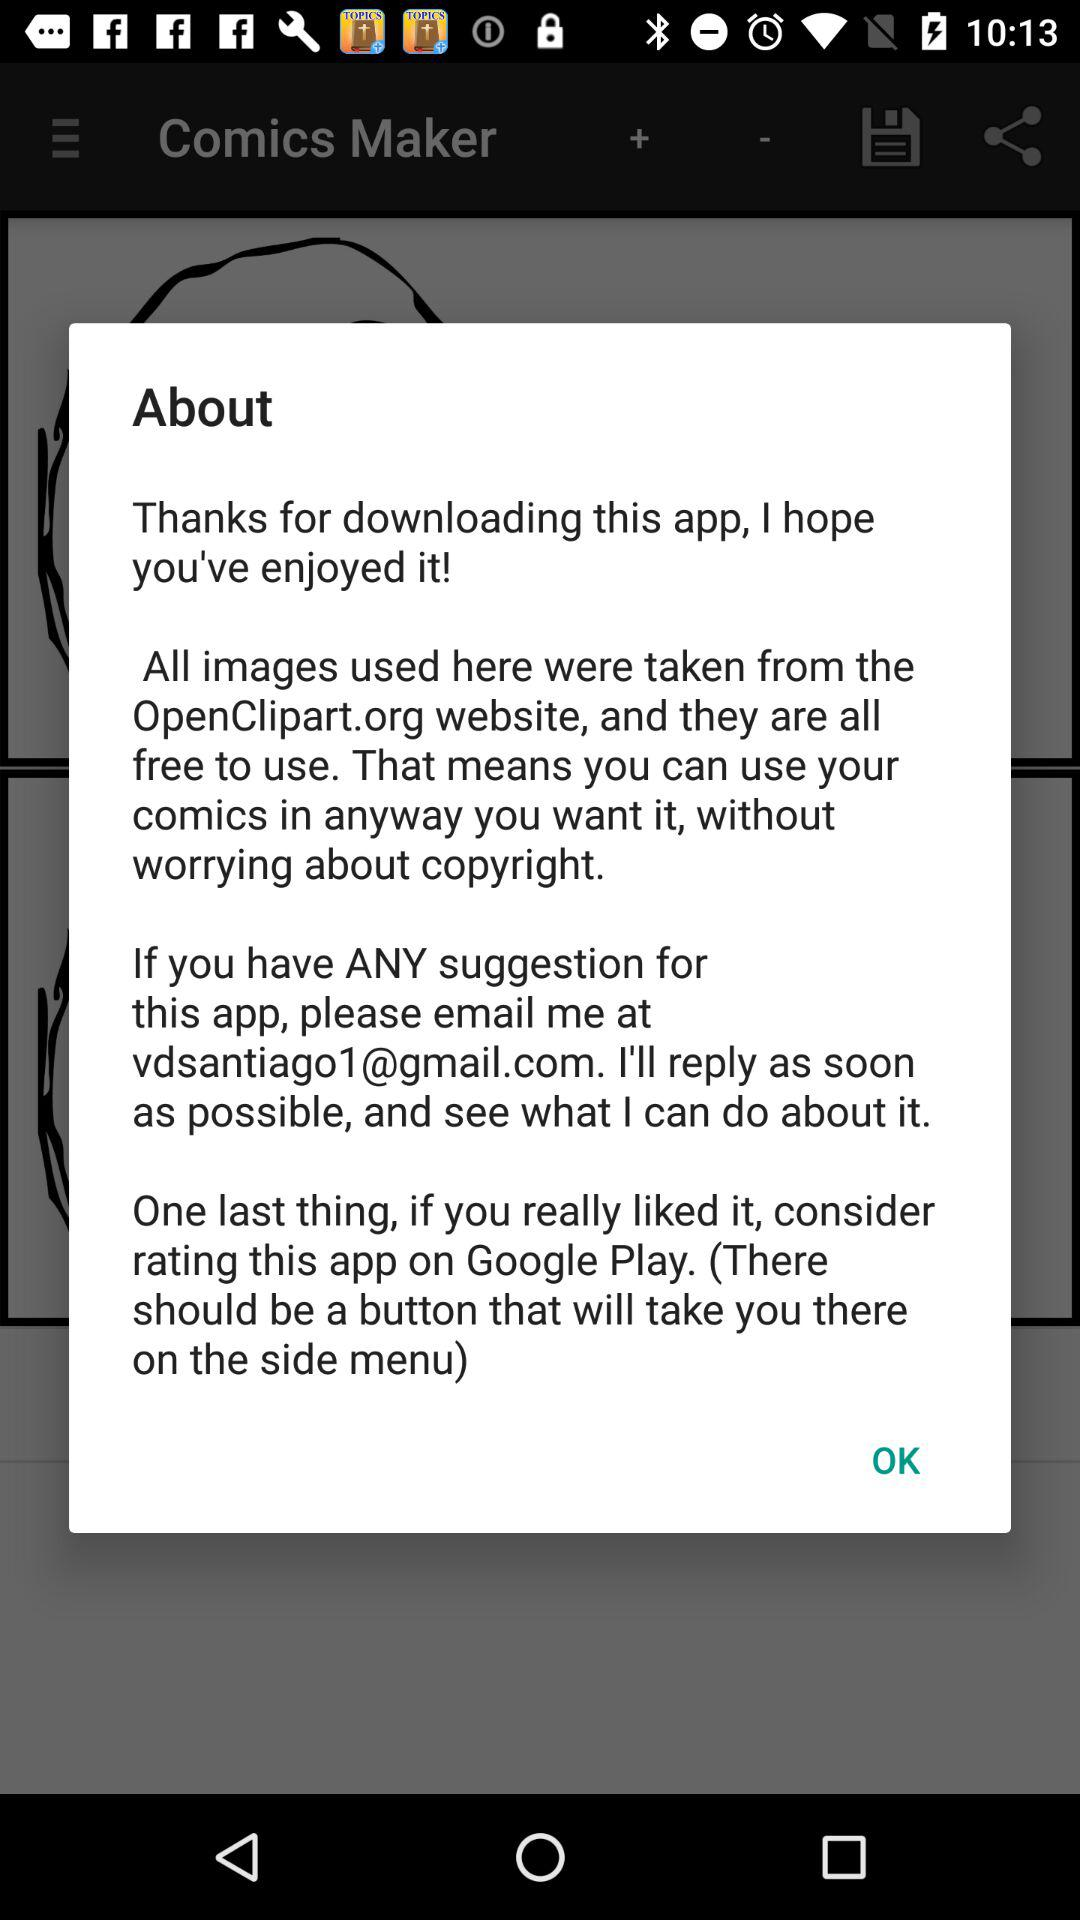At which email address can we mail for any suggestion? You can mail at vdsantiago1@gmail.com for any suggestion. 